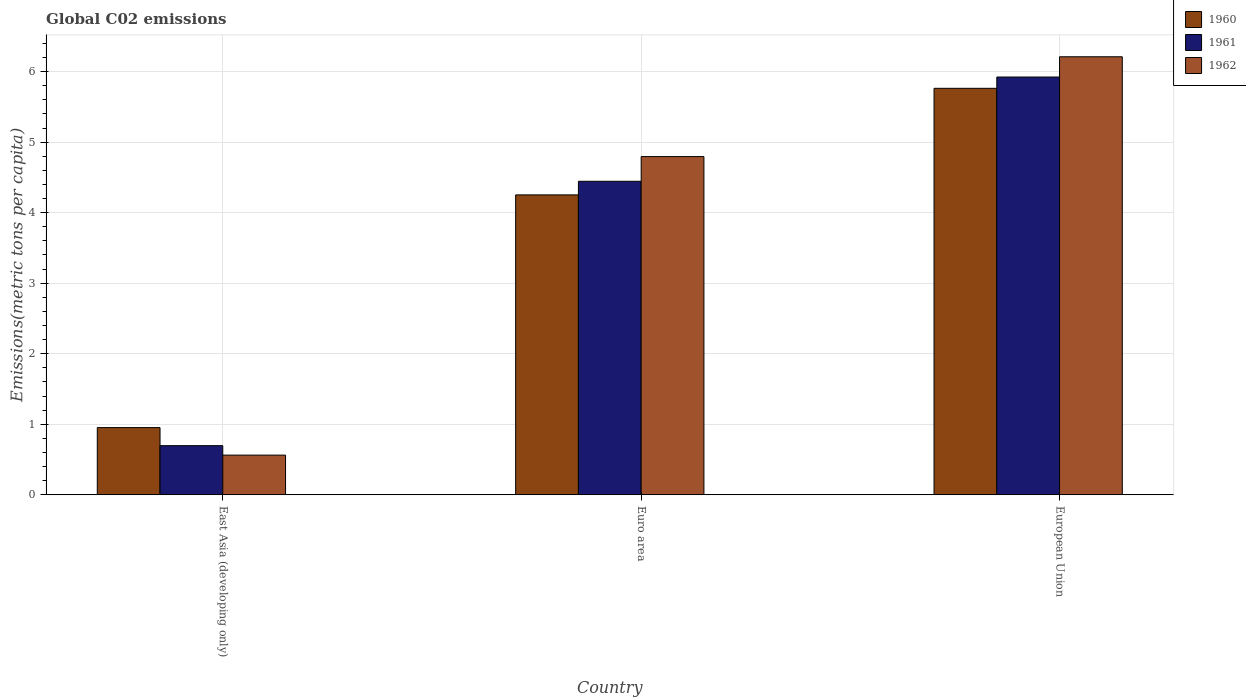How many groups of bars are there?
Give a very brief answer. 3. Are the number of bars per tick equal to the number of legend labels?
Give a very brief answer. Yes. What is the label of the 2nd group of bars from the left?
Offer a terse response. Euro area. What is the amount of CO2 emitted in in 1961 in East Asia (developing only)?
Your answer should be very brief. 0.7. Across all countries, what is the maximum amount of CO2 emitted in in 1960?
Ensure brevity in your answer.  5.76. Across all countries, what is the minimum amount of CO2 emitted in in 1962?
Keep it short and to the point. 0.56. In which country was the amount of CO2 emitted in in 1962 maximum?
Offer a terse response. European Union. In which country was the amount of CO2 emitted in in 1961 minimum?
Your answer should be compact. East Asia (developing only). What is the total amount of CO2 emitted in in 1960 in the graph?
Provide a short and direct response. 10.97. What is the difference between the amount of CO2 emitted in in 1960 in Euro area and that in European Union?
Provide a short and direct response. -1.51. What is the difference between the amount of CO2 emitted in in 1960 in European Union and the amount of CO2 emitted in in 1961 in East Asia (developing only)?
Make the answer very short. 5.07. What is the average amount of CO2 emitted in in 1960 per country?
Offer a very short reply. 3.66. What is the difference between the amount of CO2 emitted in of/in 1962 and amount of CO2 emitted in of/in 1961 in European Union?
Make the answer very short. 0.29. In how many countries, is the amount of CO2 emitted in in 1961 greater than 2 metric tons per capita?
Give a very brief answer. 2. What is the ratio of the amount of CO2 emitted in in 1961 in East Asia (developing only) to that in Euro area?
Your response must be concise. 0.16. Is the amount of CO2 emitted in in 1961 in Euro area less than that in European Union?
Keep it short and to the point. Yes. Is the difference between the amount of CO2 emitted in in 1962 in Euro area and European Union greater than the difference between the amount of CO2 emitted in in 1961 in Euro area and European Union?
Offer a very short reply. Yes. What is the difference between the highest and the second highest amount of CO2 emitted in in 1962?
Offer a very short reply. -4.23. What is the difference between the highest and the lowest amount of CO2 emitted in in 1961?
Give a very brief answer. 5.23. What does the 2nd bar from the left in Euro area represents?
Make the answer very short. 1961. Does the graph contain grids?
Provide a short and direct response. Yes. Where does the legend appear in the graph?
Your response must be concise. Top right. How are the legend labels stacked?
Offer a terse response. Vertical. What is the title of the graph?
Offer a very short reply. Global C02 emissions. Does "1964" appear as one of the legend labels in the graph?
Offer a very short reply. No. What is the label or title of the Y-axis?
Your response must be concise. Emissions(metric tons per capita). What is the Emissions(metric tons per capita) of 1960 in East Asia (developing only)?
Ensure brevity in your answer.  0.95. What is the Emissions(metric tons per capita) in 1961 in East Asia (developing only)?
Provide a succinct answer. 0.7. What is the Emissions(metric tons per capita) in 1962 in East Asia (developing only)?
Ensure brevity in your answer.  0.56. What is the Emissions(metric tons per capita) of 1960 in Euro area?
Make the answer very short. 4.25. What is the Emissions(metric tons per capita) of 1961 in Euro area?
Provide a short and direct response. 4.45. What is the Emissions(metric tons per capita) of 1962 in Euro area?
Your answer should be very brief. 4.79. What is the Emissions(metric tons per capita) of 1960 in European Union?
Your answer should be very brief. 5.76. What is the Emissions(metric tons per capita) in 1961 in European Union?
Make the answer very short. 5.92. What is the Emissions(metric tons per capita) of 1962 in European Union?
Your response must be concise. 6.21. Across all countries, what is the maximum Emissions(metric tons per capita) in 1960?
Make the answer very short. 5.76. Across all countries, what is the maximum Emissions(metric tons per capita) in 1961?
Provide a succinct answer. 5.92. Across all countries, what is the maximum Emissions(metric tons per capita) of 1962?
Give a very brief answer. 6.21. Across all countries, what is the minimum Emissions(metric tons per capita) of 1960?
Keep it short and to the point. 0.95. Across all countries, what is the minimum Emissions(metric tons per capita) of 1961?
Ensure brevity in your answer.  0.7. Across all countries, what is the minimum Emissions(metric tons per capita) of 1962?
Your response must be concise. 0.56. What is the total Emissions(metric tons per capita) of 1960 in the graph?
Make the answer very short. 10.97. What is the total Emissions(metric tons per capita) of 1961 in the graph?
Give a very brief answer. 11.06. What is the total Emissions(metric tons per capita) of 1962 in the graph?
Keep it short and to the point. 11.57. What is the difference between the Emissions(metric tons per capita) of 1960 in East Asia (developing only) and that in Euro area?
Provide a succinct answer. -3.3. What is the difference between the Emissions(metric tons per capita) of 1961 in East Asia (developing only) and that in Euro area?
Provide a short and direct response. -3.75. What is the difference between the Emissions(metric tons per capita) of 1962 in East Asia (developing only) and that in Euro area?
Provide a succinct answer. -4.23. What is the difference between the Emissions(metric tons per capita) in 1960 in East Asia (developing only) and that in European Union?
Provide a short and direct response. -4.81. What is the difference between the Emissions(metric tons per capita) in 1961 in East Asia (developing only) and that in European Union?
Provide a short and direct response. -5.23. What is the difference between the Emissions(metric tons per capita) of 1962 in East Asia (developing only) and that in European Union?
Make the answer very short. -5.65. What is the difference between the Emissions(metric tons per capita) in 1960 in Euro area and that in European Union?
Your answer should be compact. -1.51. What is the difference between the Emissions(metric tons per capita) of 1961 in Euro area and that in European Union?
Provide a short and direct response. -1.48. What is the difference between the Emissions(metric tons per capita) in 1962 in Euro area and that in European Union?
Make the answer very short. -1.42. What is the difference between the Emissions(metric tons per capita) of 1960 in East Asia (developing only) and the Emissions(metric tons per capita) of 1961 in Euro area?
Make the answer very short. -3.49. What is the difference between the Emissions(metric tons per capita) in 1960 in East Asia (developing only) and the Emissions(metric tons per capita) in 1962 in Euro area?
Provide a succinct answer. -3.84. What is the difference between the Emissions(metric tons per capita) in 1961 in East Asia (developing only) and the Emissions(metric tons per capita) in 1962 in Euro area?
Your answer should be compact. -4.1. What is the difference between the Emissions(metric tons per capita) of 1960 in East Asia (developing only) and the Emissions(metric tons per capita) of 1961 in European Union?
Your answer should be compact. -4.97. What is the difference between the Emissions(metric tons per capita) of 1960 in East Asia (developing only) and the Emissions(metric tons per capita) of 1962 in European Union?
Offer a very short reply. -5.26. What is the difference between the Emissions(metric tons per capita) in 1961 in East Asia (developing only) and the Emissions(metric tons per capita) in 1962 in European Union?
Your response must be concise. -5.51. What is the difference between the Emissions(metric tons per capita) of 1960 in Euro area and the Emissions(metric tons per capita) of 1961 in European Union?
Offer a very short reply. -1.67. What is the difference between the Emissions(metric tons per capita) in 1960 in Euro area and the Emissions(metric tons per capita) in 1962 in European Union?
Give a very brief answer. -1.96. What is the difference between the Emissions(metric tons per capita) of 1961 in Euro area and the Emissions(metric tons per capita) of 1962 in European Union?
Ensure brevity in your answer.  -1.77. What is the average Emissions(metric tons per capita) in 1960 per country?
Provide a short and direct response. 3.66. What is the average Emissions(metric tons per capita) of 1961 per country?
Ensure brevity in your answer.  3.69. What is the average Emissions(metric tons per capita) of 1962 per country?
Keep it short and to the point. 3.86. What is the difference between the Emissions(metric tons per capita) in 1960 and Emissions(metric tons per capita) in 1961 in East Asia (developing only)?
Give a very brief answer. 0.26. What is the difference between the Emissions(metric tons per capita) of 1960 and Emissions(metric tons per capita) of 1962 in East Asia (developing only)?
Offer a terse response. 0.39. What is the difference between the Emissions(metric tons per capita) in 1961 and Emissions(metric tons per capita) in 1962 in East Asia (developing only)?
Provide a succinct answer. 0.13. What is the difference between the Emissions(metric tons per capita) in 1960 and Emissions(metric tons per capita) in 1961 in Euro area?
Your answer should be very brief. -0.19. What is the difference between the Emissions(metric tons per capita) of 1960 and Emissions(metric tons per capita) of 1962 in Euro area?
Provide a short and direct response. -0.54. What is the difference between the Emissions(metric tons per capita) in 1961 and Emissions(metric tons per capita) in 1962 in Euro area?
Your answer should be very brief. -0.35. What is the difference between the Emissions(metric tons per capita) of 1960 and Emissions(metric tons per capita) of 1961 in European Union?
Make the answer very short. -0.16. What is the difference between the Emissions(metric tons per capita) of 1960 and Emissions(metric tons per capita) of 1962 in European Union?
Give a very brief answer. -0.45. What is the difference between the Emissions(metric tons per capita) in 1961 and Emissions(metric tons per capita) in 1962 in European Union?
Provide a succinct answer. -0.29. What is the ratio of the Emissions(metric tons per capita) in 1960 in East Asia (developing only) to that in Euro area?
Give a very brief answer. 0.22. What is the ratio of the Emissions(metric tons per capita) in 1961 in East Asia (developing only) to that in Euro area?
Provide a short and direct response. 0.16. What is the ratio of the Emissions(metric tons per capita) in 1962 in East Asia (developing only) to that in Euro area?
Ensure brevity in your answer.  0.12. What is the ratio of the Emissions(metric tons per capita) of 1960 in East Asia (developing only) to that in European Union?
Offer a very short reply. 0.17. What is the ratio of the Emissions(metric tons per capita) of 1961 in East Asia (developing only) to that in European Union?
Your response must be concise. 0.12. What is the ratio of the Emissions(metric tons per capita) of 1962 in East Asia (developing only) to that in European Union?
Provide a short and direct response. 0.09. What is the ratio of the Emissions(metric tons per capita) of 1960 in Euro area to that in European Union?
Offer a terse response. 0.74. What is the ratio of the Emissions(metric tons per capita) in 1961 in Euro area to that in European Union?
Offer a terse response. 0.75. What is the ratio of the Emissions(metric tons per capita) of 1962 in Euro area to that in European Union?
Your answer should be compact. 0.77. What is the difference between the highest and the second highest Emissions(metric tons per capita) of 1960?
Your response must be concise. 1.51. What is the difference between the highest and the second highest Emissions(metric tons per capita) of 1961?
Provide a short and direct response. 1.48. What is the difference between the highest and the second highest Emissions(metric tons per capita) of 1962?
Ensure brevity in your answer.  1.42. What is the difference between the highest and the lowest Emissions(metric tons per capita) of 1960?
Ensure brevity in your answer.  4.81. What is the difference between the highest and the lowest Emissions(metric tons per capita) in 1961?
Offer a very short reply. 5.23. What is the difference between the highest and the lowest Emissions(metric tons per capita) of 1962?
Provide a short and direct response. 5.65. 